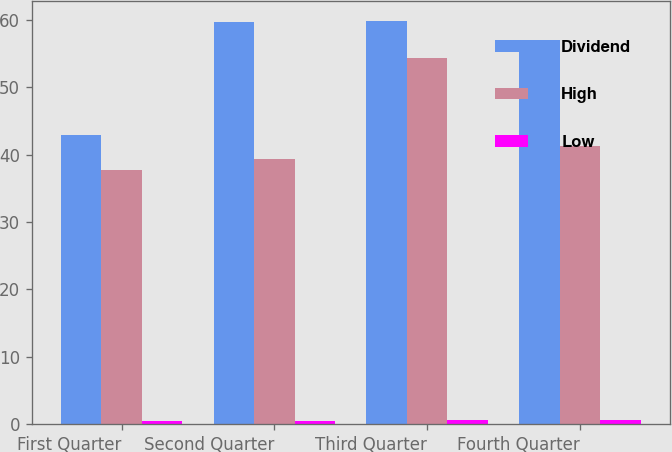Convert chart to OTSL. <chart><loc_0><loc_0><loc_500><loc_500><stacked_bar_chart><ecel><fcel>First Quarter<fcel>Second Quarter<fcel>Third Quarter<fcel>Fourth Quarter<nl><fcel>Dividend<fcel>42.94<fcel>59.68<fcel>59.77<fcel>57<nl><fcel>High<fcel>37.77<fcel>39.31<fcel>54.28<fcel>41.21<nl><fcel>Low<fcel>0.4<fcel>0.42<fcel>0.56<fcel>0.57<nl></chart> 